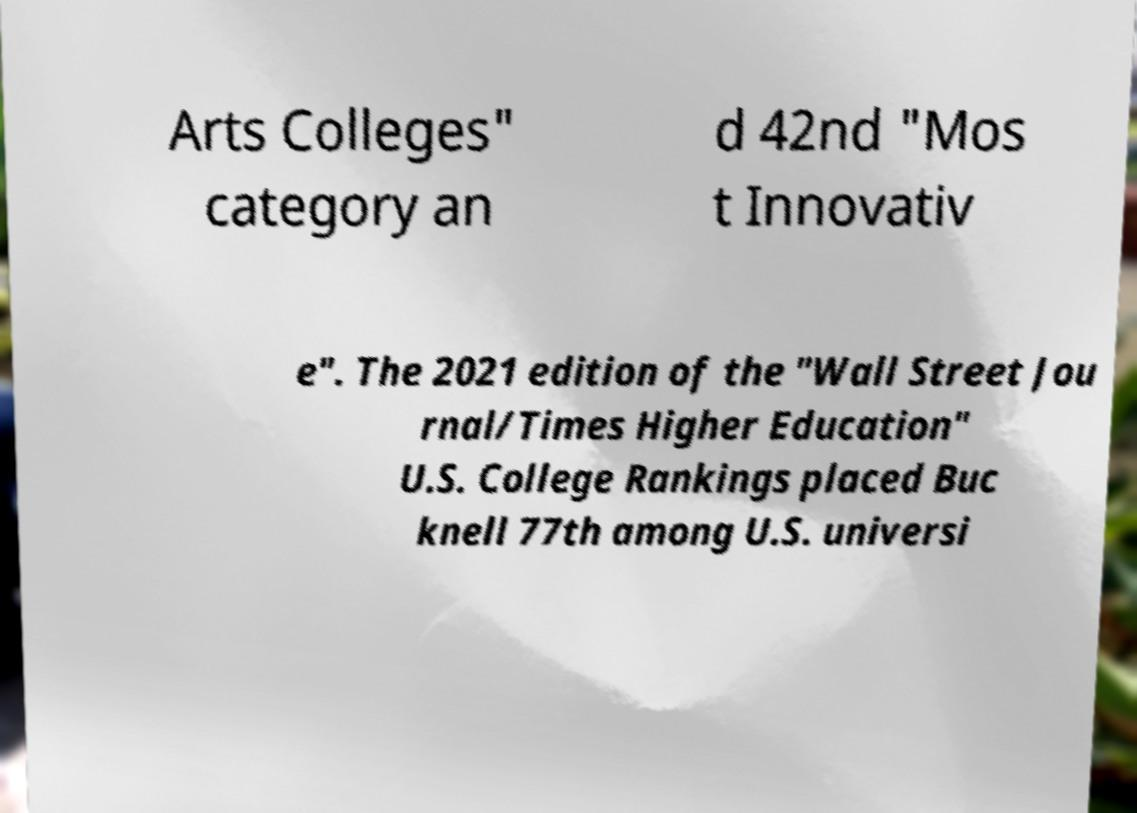Please identify and transcribe the text found in this image. Arts Colleges" category an d 42nd "Mos t Innovativ e". The 2021 edition of the "Wall Street Jou rnal/Times Higher Education" U.S. College Rankings placed Buc knell 77th among U.S. universi 